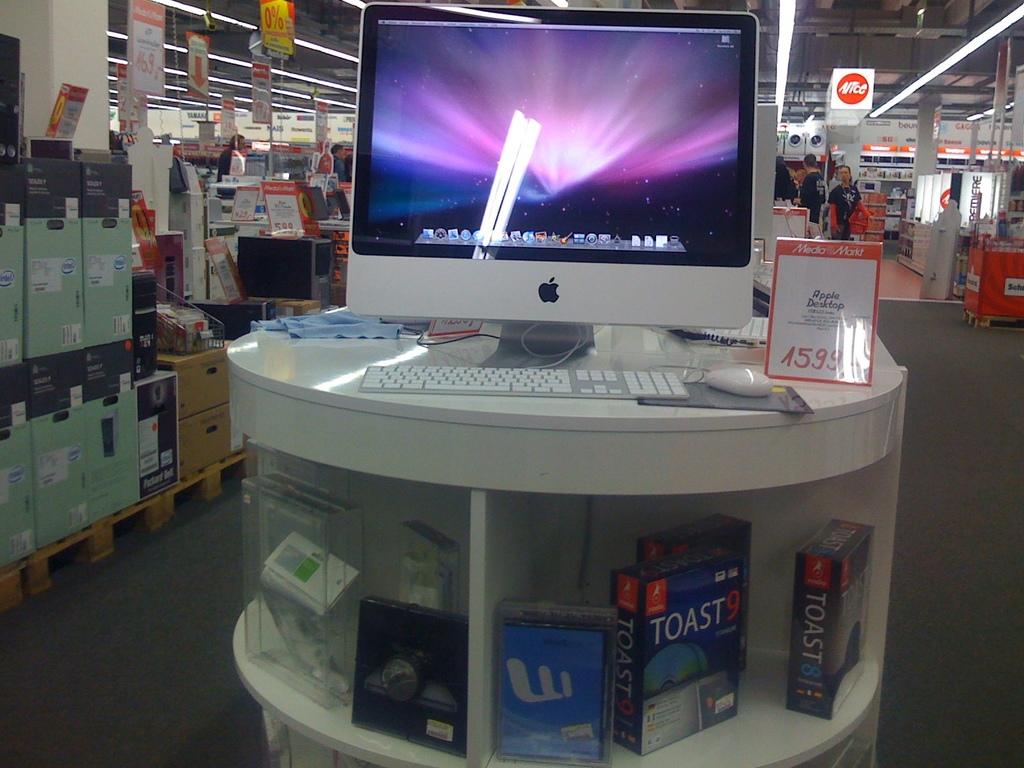What software is down at the bottom?
Offer a terse response. Toast. What is the name of the store?
Offer a terse response. Media markt. 